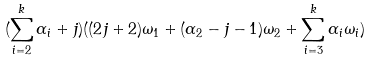<formula> <loc_0><loc_0><loc_500><loc_500>( \sum _ { i = 2 } ^ { k } \alpha _ { i } + j ) ( ( 2 j + 2 ) \omega _ { 1 } + ( \alpha _ { 2 } - j - 1 ) \omega _ { 2 } + \sum _ { i = 3 } ^ { k } \alpha _ { i } \omega _ { i } )</formula> 